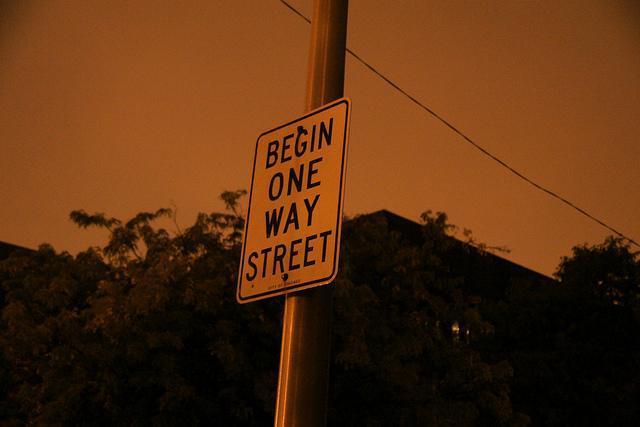How many one way signs?
Give a very brief answer. 1. 